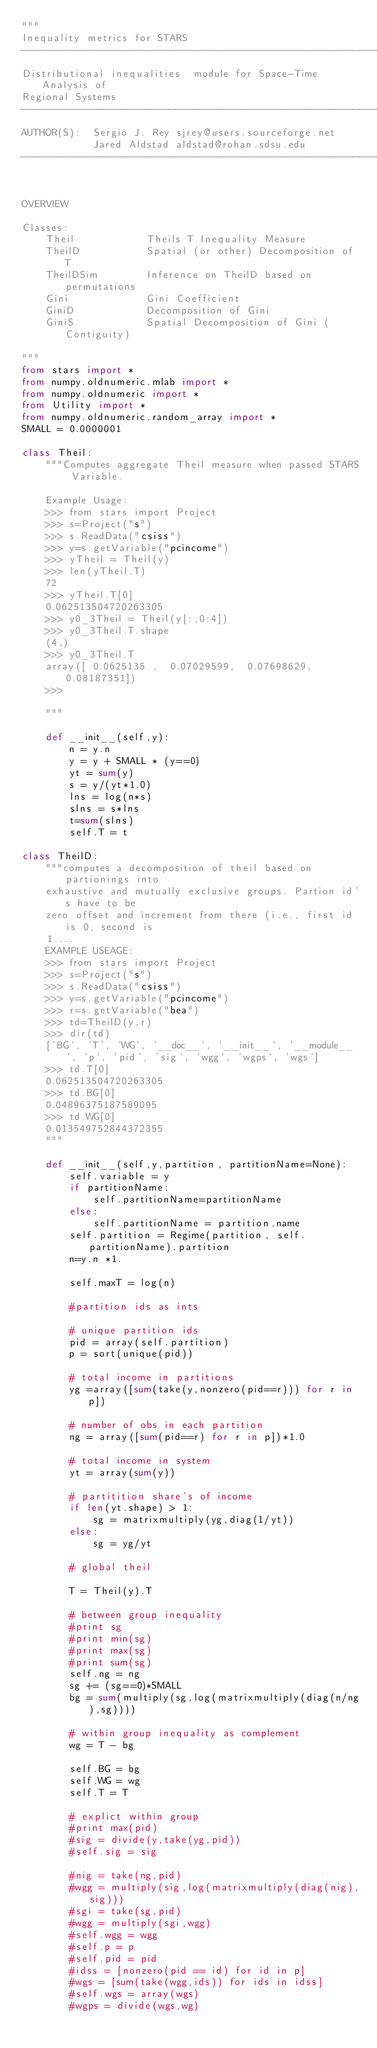Convert code to text. <code><loc_0><loc_0><loc_500><loc_500><_Python_>"""
Inequality metrics for STARS
----------------------------------------------------------------------
Distributional inequalities  module for Space-Time Analysis of
Regional Systems
----------------------------------------------------------------------
AUTHOR(S):  Sergio J. Rey sjrey@users.sourceforge.net
            Jared Aldstad aldstad@rohan.sdsu.edu
----------------------------------------------------------------------


OVERVIEW

Classes:
    Theil            Theils T Inequality Measure
    TheilD           Spatial (or other) Decomposition of T
    TheilDSim        Inference on TheilD based on permutations
    Gini             Gini Coefficient
    GiniD            Decomposition of Gini 
    GiniS            Spatial Decomposition of Gini (Contiguity)

"""
from stars import *
from numpy.oldnumeric.mlab import *
from numpy.oldnumeric import *
from Utility import *
from numpy.oldnumeric.random_array import *
SMALL = 0.0000001

class Theil:
    """Computes aggregate Theil measure when passed STARS Variable. 

    Example Usage:
    >>> from stars import Project
    >>> s=Project("s")
    >>> s.ReadData("csiss")
    >>> y=s.getVariable("pcincome")
    >>> yTheil = Theil(y)
    >>> len(yTheil.T)
    72
    >>> yTheil.T[0]
    0.062513504720263305
    >>> y0_3Theil = Theil(y[:,0:4])
    >>> y0_3Theil.T.shape
    (4,)
    >>> y0_3Theil.T
    array([ 0.0625135 ,  0.07029599,  0.07698629,  0.08187351])
    >>> 

    """

    def __init__(self,y):
        n = y.n
        y = y + SMALL * (y==0)
        yt = sum(y)
        s = y/(yt*1.0)
        lns = log(n*s)
        slns = s*lns
        t=sum(slns)
        self.T = t

class TheilD:
    """computes a decomposition of theil based on partionings into
    exhaustive and mutually exclusive groups. Partion id's have to be
    zero offset and increment from there (i.e., first id is 0, second is
    1....
    EXAMPLE USEAGE:
    >>> from stars import Project
    >>> s=Project("s")
    >>> s.ReadData("csiss")
    >>> y=s.getVariable("pcincome")
    >>> r=s.getVariable("bea")
    >>> td=TheilD(y,r)
    >>> dir(td)
    ['BG', 'T', 'WG', '__doc__', '__init__', '__module__', 'p', 'pid', 'sig', 'wgg', 'wgps', 'wgs']
    >>> td.T[0]
    0.062513504720263305
    >>> td.BG[0]
    0.04896375187589095
    >>> td.WG[0]
    0.013549752844372355
    """

    def __init__(self,y,partition, partitionName=None):
        self.variable = y
        if partitionName:
            self.partitionName=partitionName
        else:
            self.partitionName = partition.name
        self.partition = Regime(partition, self.partitionName).partition
        n=y.n *1.

        self.maxT = log(n)

        #partition ids as ints

        # unique partition ids
        pid = array(self.partition)
        p = sort(unique(pid))
        
        # total income in partitions
        yg =array([sum(take(y,nonzero(pid==r))) for r in p])

        # number of obs in each partition
        ng = array([sum(pid==r) for r in p])*1.0

        # total income in system
        yt = array(sum(y))

        # partitition share's of income
        if len(yt.shape) > 1:
            sg = matrixmultiply(yg,diag(1/yt))
        else:
            sg = yg/yt

        # global theil

        T = Theil(y).T

        # between group inequality
        #print sg
        #print min(sg)
        #print max(sg)
        #print sum(sg)
        self.ng = ng
        sg += (sg==0)*SMALL
        bg = sum(multiply(sg,log(matrixmultiply(diag(n/ng),sg))))

        # within group inequality as complement
        wg = T - bg

        self.BG = bg
        self.WG = wg
        self.T = T

        # explict within group
        #print max(pid)
        #sig = divide(y,take(yg,pid))
        #self.sig = sig

        #nig = take(ng,pid)
        #wgg = multiply(sig,log(matrixmultiply(diag(nig),sig)))
        #sgi = take(sg,pid)
        #wgg = multiply(sgi,wgg)
        #self.wgg = wgg
        #self.p = p
        #self.pid = pid
        #idss = [nonzero(pid == id) for id in p]
        #wgs = [sum(take(wgg,ids)) for ids in idss]
        #self.wgs = array(wgs)
        #wgps = divide(wgs,wg)</code> 